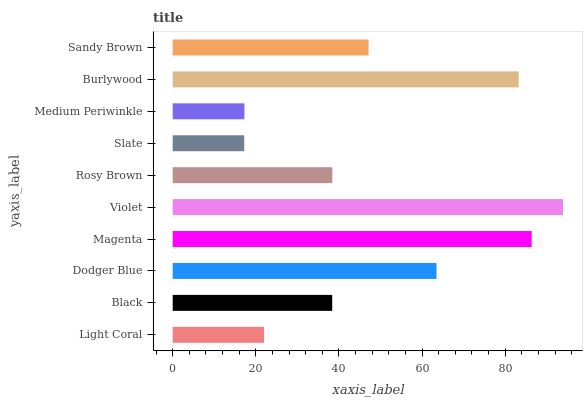Is Slate the minimum?
Answer yes or no. Yes. Is Violet the maximum?
Answer yes or no. Yes. Is Black the minimum?
Answer yes or no. No. Is Black the maximum?
Answer yes or no. No. Is Black greater than Light Coral?
Answer yes or no. Yes. Is Light Coral less than Black?
Answer yes or no. Yes. Is Light Coral greater than Black?
Answer yes or no. No. Is Black less than Light Coral?
Answer yes or no. No. Is Sandy Brown the high median?
Answer yes or no. Yes. Is Rosy Brown the low median?
Answer yes or no. Yes. Is Magenta the high median?
Answer yes or no. No. Is Black the low median?
Answer yes or no. No. 